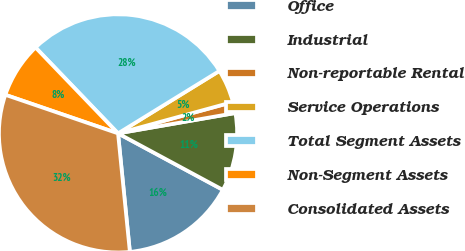Convert chart to OTSL. <chart><loc_0><loc_0><loc_500><loc_500><pie_chart><fcel>Office<fcel>Industrial<fcel>Non-reportable Rental<fcel>Service Operations<fcel>Total Segment Assets<fcel>Non-Segment Assets<fcel>Consolidated Assets<nl><fcel>15.55%<fcel>10.6%<fcel>1.51%<fcel>4.54%<fcel>28.39%<fcel>7.57%<fcel>31.83%<nl></chart> 